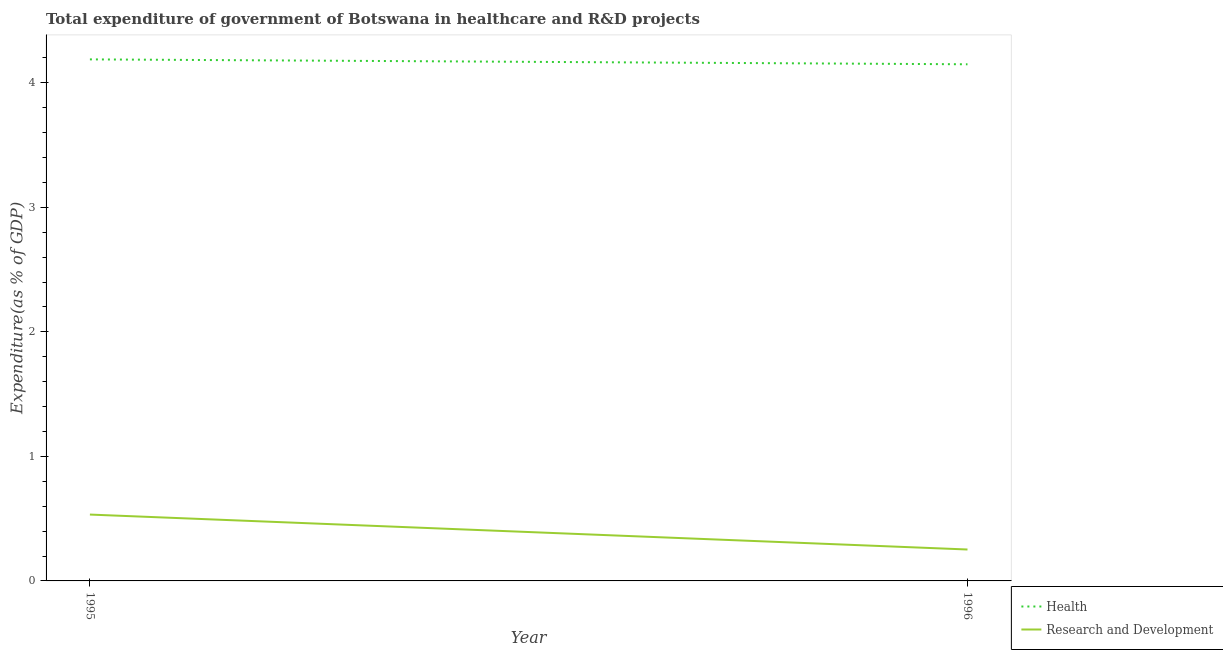Does the line corresponding to expenditure in r&d intersect with the line corresponding to expenditure in healthcare?
Provide a succinct answer. No. What is the expenditure in healthcare in 1995?
Your answer should be very brief. 4.19. Across all years, what is the maximum expenditure in healthcare?
Ensure brevity in your answer.  4.19. Across all years, what is the minimum expenditure in r&d?
Keep it short and to the point. 0.25. In which year was the expenditure in healthcare maximum?
Provide a short and direct response. 1995. What is the total expenditure in healthcare in the graph?
Ensure brevity in your answer.  8.34. What is the difference between the expenditure in r&d in 1995 and that in 1996?
Provide a succinct answer. 0.28. What is the difference between the expenditure in r&d in 1996 and the expenditure in healthcare in 1995?
Ensure brevity in your answer.  -3.94. What is the average expenditure in healthcare per year?
Your response must be concise. 4.17. In the year 1996, what is the difference between the expenditure in healthcare and expenditure in r&d?
Make the answer very short. 3.9. In how many years, is the expenditure in healthcare greater than 3.2 %?
Ensure brevity in your answer.  2. What is the ratio of the expenditure in healthcare in 1995 to that in 1996?
Give a very brief answer. 1.01. Does the expenditure in healthcare monotonically increase over the years?
Your answer should be compact. No. Is the expenditure in r&d strictly less than the expenditure in healthcare over the years?
Your response must be concise. Yes. How many lines are there?
Provide a succinct answer. 2. How many years are there in the graph?
Keep it short and to the point. 2. What is the difference between two consecutive major ticks on the Y-axis?
Make the answer very short. 1. Does the graph contain grids?
Provide a short and direct response. No. How many legend labels are there?
Offer a very short reply. 2. How are the legend labels stacked?
Offer a very short reply. Vertical. What is the title of the graph?
Make the answer very short. Total expenditure of government of Botswana in healthcare and R&D projects. Does "Food" appear as one of the legend labels in the graph?
Your response must be concise. No. What is the label or title of the Y-axis?
Provide a short and direct response. Expenditure(as % of GDP). What is the Expenditure(as % of GDP) of Health in 1995?
Give a very brief answer. 4.19. What is the Expenditure(as % of GDP) in Research and Development in 1995?
Your answer should be very brief. 0.53. What is the Expenditure(as % of GDP) in Health in 1996?
Your answer should be compact. 4.15. What is the Expenditure(as % of GDP) in Research and Development in 1996?
Offer a terse response. 0.25. Across all years, what is the maximum Expenditure(as % of GDP) of Health?
Give a very brief answer. 4.19. Across all years, what is the maximum Expenditure(as % of GDP) in Research and Development?
Give a very brief answer. 0.53. Across all years, what is the minimum Expenditure(as % of GDP) of Health?
Offer a very short reply. 4.15. Across all years, what is the minimum Expenditure(as % of GDP) of Research and Development?
Provide a succinct answer. 0.25. What is the total Expenditure(as % of GDP) in Health in the graph?
Your answer should be compact. 8.34. What is the total Expenditure(as % of GDP) of Research and Development in the graph?
Your answer should be very brief. 0.79. What is the difference between the Expenditure(as % of GDP) in Health in 1995 and that in 1996?
Keep it short and to the point. 0.04. What is the difference between the Expenditure(as % of GDP) of Research and Development in 1995 and that in 1996?
Your response must be concise. 0.28. What is the difference between the Expenditure(as % of GDP) in Health in 1995 and the Expenditure(as % of GDP) in Research and Development in 1996?
Make the answer very short. 3.94. What is the average Expenditure(as % of GDP) of Health per year?
Your answer should be compact. 4.17. What is the average Expenditure(as % of GDP) in Research and Development per year?
Your answer should be compact. 0.39. In the year 1995, what is the difference between the Expenditure(as % of GDP) of Health and Expenditure(as % of GDP) of Research and Development?
Ensure brevity in your answer.  3.66. In the year 1996, what is the difference between the Expenditure(as % of GDP) of Health and Expenditure(as % of GDP) of Research and Development?
Provide a short and direct response. 3.9. What is the ratio of the Expenditure(as % of GDP) of Health in 1995 to that in 1996?
Provide a short and direct response. 1.01. What is the ratio of the Expenditure(as % of GDP) in Research and Development in 1995 to that in 1996?
Your answer should be compact. 2.11. What is the difference between the highest and the second highest Expenditure(as % of GDP) of Health?
Provide a succinct answer. 0.04. What is the difference between the highest and the second highest Expenditure(as % of GDP) in Research and Development?
Make the answer very short. 0.28. What is the difference between the highest and the lowest Expenditure(as % of GDP) of Health?
Give a very brief answer. 0.04. What is the difference between the highest and the lowest Expenditure(as % of GDP) in Research and Development?
Your response must be concise. 0.28. 